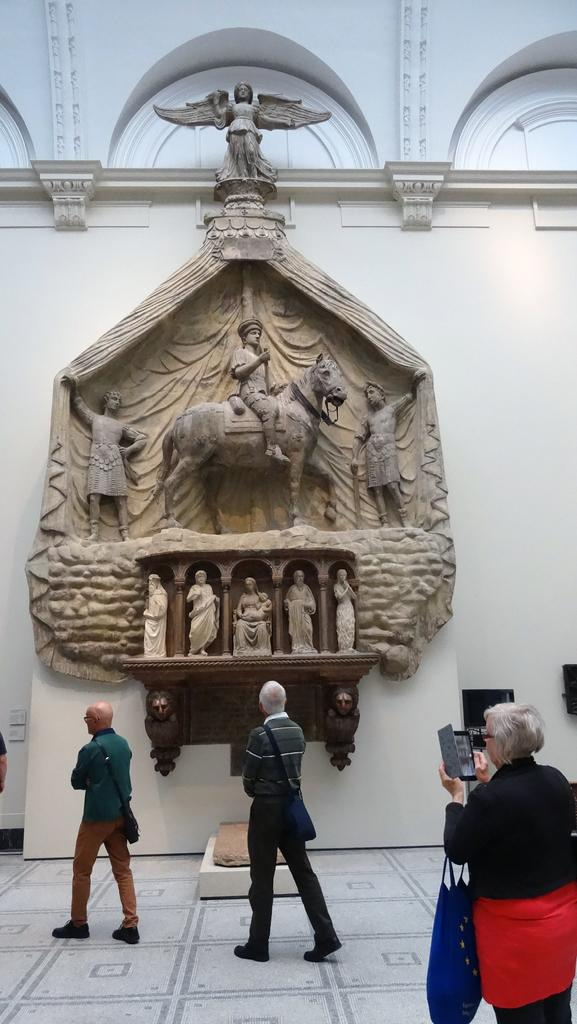How many people are walking in the image? There are three people walking in the image. What is at the bottom of the image? There is a floor at the bottom of the image. What can be seen in the background of the image? There is a wall, wooden art, and sculptures in thes in the background of the image. What type of glass is being used to create the sculptures in the image? There is no glass present in the image; the sculptures are not made of glass. 